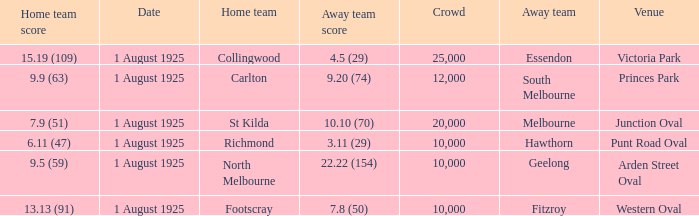Parse the table in full. {'header': ['Home team score', 'Date', 'Home team', 'Away team score', 'Crowd', 'Away team', 'Venue'], 'rows': [['15.19 (109)', '1 August 1925', 'Collingwood', '4.5 (29)', '25,000', 'Essendon', 'Victoria Park'], ['9.9 (63)', '1 August 1925', 'Carlton', '9.20 (74)', '12,000', 'South Melbourne', 'Princes Park'], ['7.9 (51)', '1 August 1925', 'St Kilda', '10.10 (70)', '20,000', 'Melbourne', 'Junction Oval'], ['6.11 (47)', '1 August 1925', 'Richmond', '3.11 (29)', '10,000', 'Hawthorn', 'Punt Road Oval'], ['9.5 (59)', '1 August 1925', 'North Melbourne', '22.22 (154)', '10,000', 'Geelong', 'Arden Street Oval'], ['13.13 (91)', '1 August 1925', 'Footscray', '7.8 (50)', '10,000', 'Fitzroy', 'Western Oval']]} What was the away team's score during the match held at the western oval? 7.8 (50). 